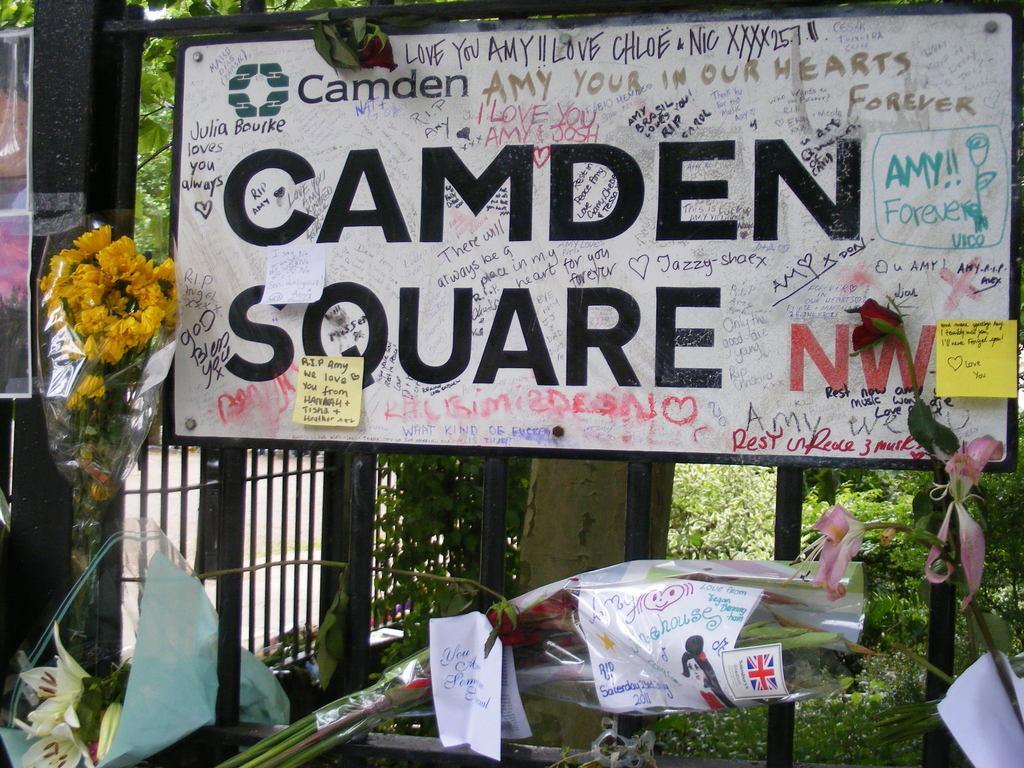Can you describe this image briefly? In this image we can see a board with poles. On the board there is text. Also there are papers with text. And there are flower bouquets. In the back there is railing. In the background there are leaves. 